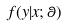Convert formula to latex. <formula><loc_0><loc_0><loc_500><loc_500>f ( y | x ; \theta )</formula> 